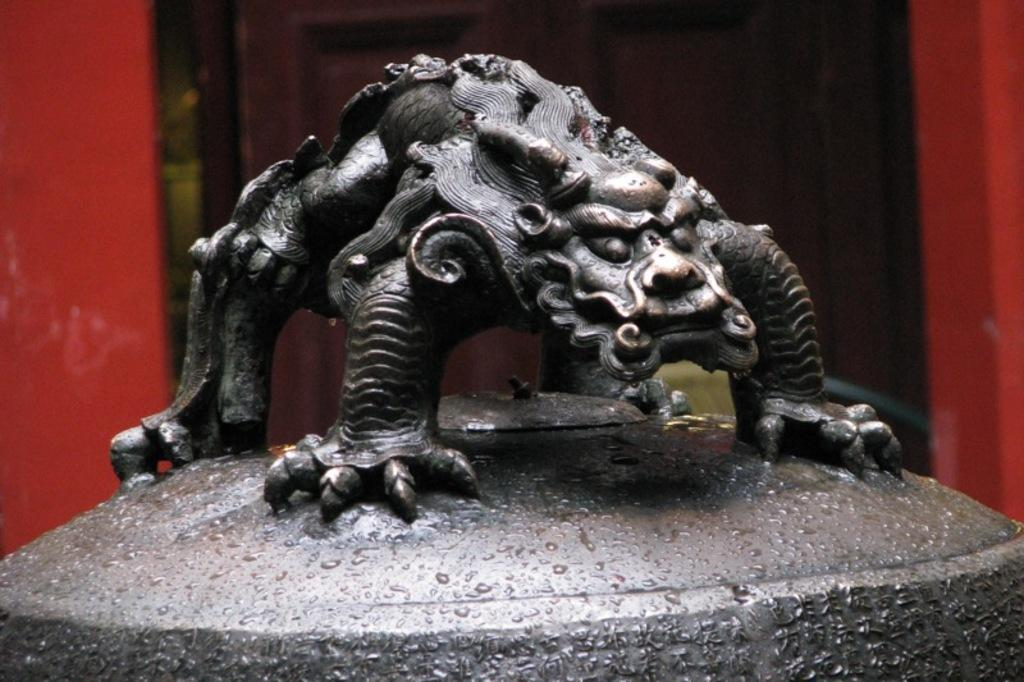What is the main subject in the center of the image? There is an iron sculpture in the center of the image. Can you describe the background of the image? There is a door in the background of the image. What type of sheep can be seen singing a song in the image? There are no sheep or singing in the image; it features an iron sculpture and a door in the background. 